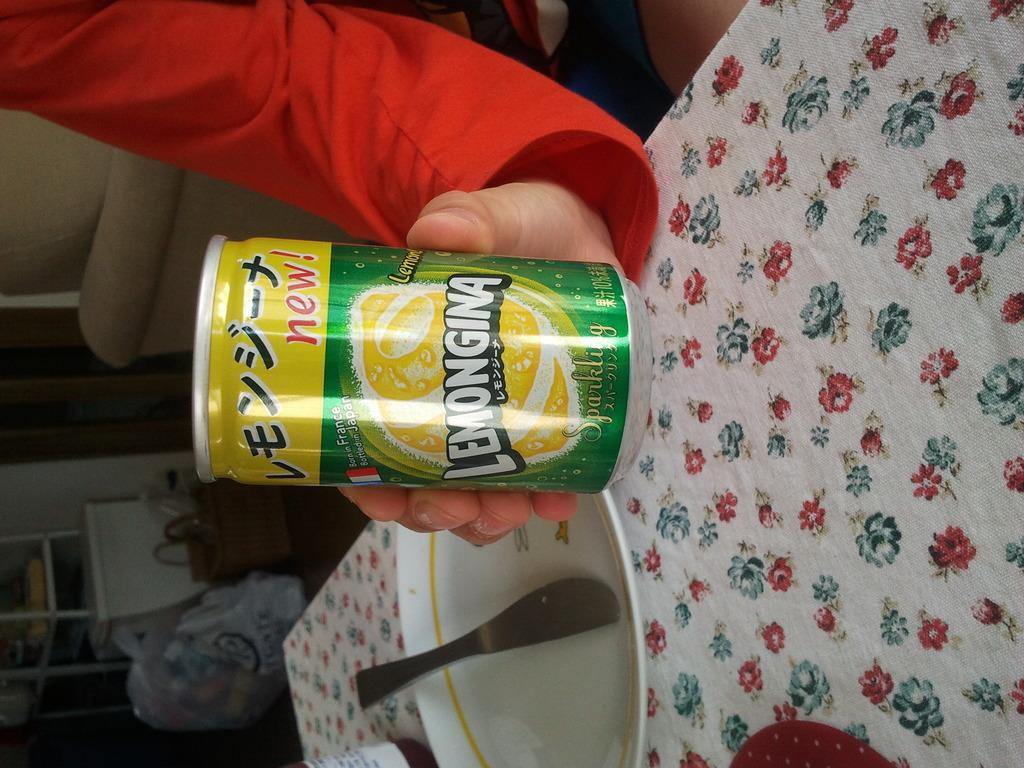<image>
Offer a succinct explanation of the picture presented. A can of Lemongina is green and yellow. 